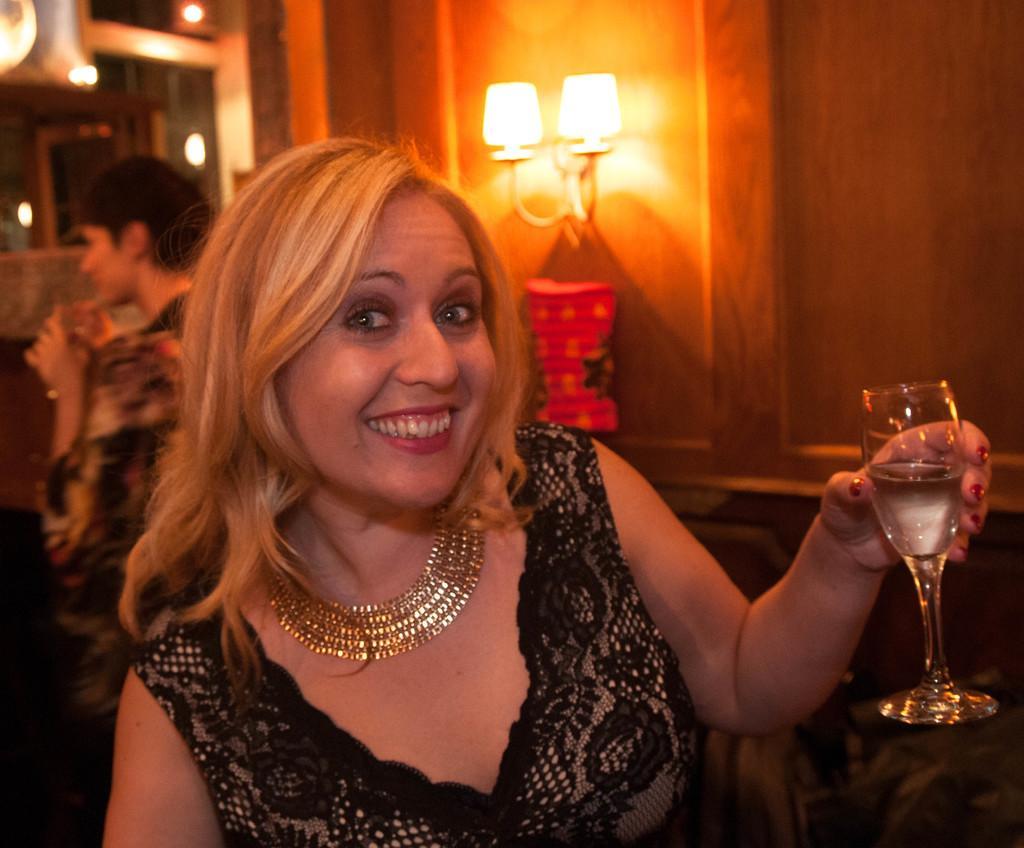How would you summarize this image in a sentence or two? In the image we can see there is a woman who is sitting and holding wine glass in her hand. 